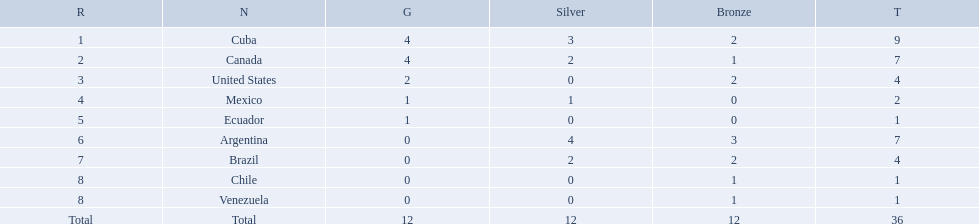What countries participated? Cuba, 4, 3, 2, Canada, 4, 2, 1, United States, 2, 0, 2, Mexico, 1, 1, 0, Ecuador, 1, 0, 0, Argentina, 0, 4, 3, Brazil, 0, 2, 2, Chile, 0, 0, 1, Venezuela, 0, 0, 1. What countries won 1 gold Mexico, 1, 1, 0, Ecuador, 1, 0, 0. What country above also won no silver? Ecuador. Which nations won gold medals? Cuba, Canada, United States, Mexico, Ecuador. How many medals did each nation win? Cuba, 9, Canada, 7, United States, 4, Mexico, 2, Ecuador, 1. Which nation only won a gold medal? Ecuador. Which countries have won gold medals? Cuba, Canada, United States, Mexico, Ecuador. Of these countries, which ones have never won silver or bronze medals? United States, Ecuador. Of the two nations listed previously, which one has only won a gold medal? Ecuador. Which nations competed in the 2011 pan american games? Cuba, Canada, United States, Mexico, Ecuador, Argentina, Brazil, Chile, Venezuela. Of these nations which ones won gold? Cuba, Canada, United States, Mexico, Ecuador. Which nation of the ones that won gold did not win silver? United States. Which nations participated? Cuba, Canada, United States, Mexico, Ecuador, Argentina, Brazil, Chile, Venezuela. Which nations won gold? Cuba, Canada, United States, Mexico, Ecuador. Which nations did not win silver? United States, Ecuador, Chile, Venezuela. Out of those countries previously listed, which nation won gold? United States. 